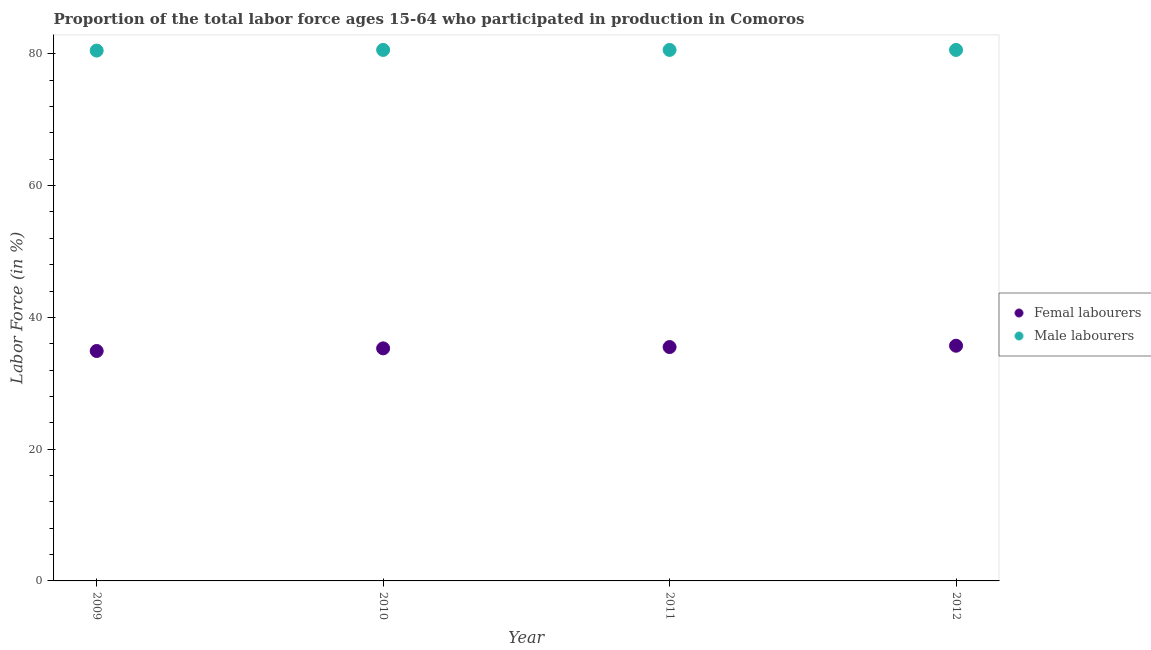What is the percentage of female labor force in 2011?
Your answer should be very brief. 35.5. Across all years, what is the maximum percentage of female labor force?
Offer a terse response. 35.7. Across all years, what is the minimum percentage of female labor force?
Your answer should be very brief. 34.9. In which year was the percentage of female labor force minimum?
Your response must be concise. 2009. What is the total percentage of male labour force in the graph?
Offer a terse response. 322.3. What is the difference between the percentage of male labour force in 2009 and that in 2012?
Make the answer very short. -0.1. What is the difference between the percentage of female labor force in 2011 and the percentage of male labour force in 2012?
Offer a very short reply. -45.1. What is the average percentage of male labour force per year?
Your answer should be compact. 80.57. In the year 2010, what is the difference between the percentage of male labour force and percentage of female labor force?
Provide a short and direct response. 45.3. In how many years, is the percentage of female labor force greater than 32 %?
Give a very brief answer. 4. What is the ratio of the percentage of male labour force in 2009 to that in 2011?
Ensure brevity in your answer.  1. Is the difference between the percentage of male labour force in 2010 and 2011 greater than the difference between the percentage of female labor force in 2010 and 2011?
Offer a very short reply. Yes. What is the difference between the highest and the second highest percentage of female labor force?
Ensure brevity in your answer.  0.2. What is the difference between the highest and the lowest percentage of male labour force?
Ensure brevity in your answer.  0.1. In how many years, is the percentage of male labour force greater than the average percentage of male labour force taken over all years?
Your answer should be compact. 3. Is the sum of the percentage of male labour force in 2010 and 2012 greater than the maximum percentage of female labor force across all years?
Your response must be concise. Yes. Is the percentage of male labour force strictly less than the percentage of female labor force over the years?
Your response must be concise. No. How many years are there in the graph?
Your response must be concise. 4. What is the difference between two consecutive major ticks on the Y-axis?
Offer a terse response. 20. Does the graph contain any zero values?
Give a very brief answer. No. Does the graph contain grids?
Make the answer very short. No. Where does the legend appear in the graph?
Your answer should be very brief. Center right. How many legend labels are there?
Offer a very short reply. 2. How are the legend labels stacked?
Your answer should be very brief. Vertical. What is the title of the graph?
Make the answer very short. Proportion of the total labor force ages 15-64 who participated in production in Comoros. Does "% of GNI" appear as one of the legend labels in the graph?
Your response must be concise. No. What is the label or title of the X-axis?
Offer a very short reply. Year. What is the label or title of the Y-axis?
Offer a terse response. Labor Force (in %). What is the Labor Force (in %) of Femal labourers in 2009?
Offer a very short reply. 34.9. What is the Labor Force (in %) of Male labourers in 2009?
Provide a short and direct response. 80.5. What is the Labor Force (in %) of Femal labourers in 2010?
Your answer should be compact. 35.3. What is the Labor Force (in %) in Male labourers in 2010?
Your answer should be very brief. 80.6. What is the Labor Force (in %) of Femal labourers in 2011?
Your answer should be very brief. 35.5. What is the Labor Force (in %) in Male labourers in 2011?
Offer a very short reply. 80.6. What is the Labor Force (in %) in Femal labourers in 2012?
Make the answer very short. 35.7. What is the Labor Force (in %) in Male labourers in 2012?
Offer a very short reply. 80.6. Across all years, what is the maximum Labor Force (in %) of Femal labourers?
Provide a short and direct response. 35.7. Across all years, what is the maximum Labor Force (in %) in Male labourers?
Make the answer very short. 80.6. Across all years, what is the minimum Labor Force (in %) in Femal labourers?
Offer a terse response. 34.9. Across all years, what is the minimum Labor Force (in %) in Male labourers?
Your response must be concise. 80.5. What is the total Labor Force (in %) in Femal labourers in the graph?
Your response must be concise. 141.4. What is the total Labor Force (in %) in Male labourers in the graph?
Offer a very short reply. 322.3. What is the difference between the Labor Force (in %) of Male labourers in 2009 and that in 2010?
Offer a very short reply. -0.1. What is the difference between the Labor Force (in %) of Femal labourers in 2009 and that in 2011?
Your answer should be compact. -0.6. What is the difference between the Labor Force (in %) in Femal labourers in 2011 and that in 2012?
Your response must be concise. -0.2. What is the difference between the Labor Force (in %) in Femal labourers in 2009 and the Labor Force (in %) in Male labourers in 2010?
Provide a succinct answer. -45.7. What is the difference between the Labor Force (in %) in Femal labourers in 2009 and the Labor Force (in %) in Male labourers in 2011?
Keep it short and to the point. -45.7. What is the difference between the Labor Force (in %) in Femal labourers in 2009 and the Labor Force (in %) in Male labourers in 2012?
Your answer should be very brief. -45.7. What is the difference between the Labor Force (in %) of Femal labourers in 2010 and the Labor Force (in %) of Male labourers in 2011?
Keep it short and to the point. -45.3. What is the difference between the Labor Force (in %) in Femal labourers in 2010 and the Labor Force (in %) in Male labourers in 2012?
Give a very brief answer. -45.3. What is the difference between the Labor Force (in %) of Femal labourers in 2011 and the Labor Force (in %) of Male labourers in 2012?
Ensure brevity in your answer.  -45.1. What is the average Labor Force (in %) in Femal labourers per year?
Make the answer very short. 35.35. What is the average Labor Force (in %) in Male labourers per year?
Ensure brevity in your answer.  80.58. In the year 2009, what is the difference between the Labor Force (in %) in Femal labourers and Labor Force (in %) in Male labourers?
Make the answer very short. -45.6. In the year 2010, what is the difference between the Labor Force (in %) in Femal labourers and Labor Force (in %) in Male labourers?
Your answer should be very brief. -45.3. In the year 2011, what is the difference between the Labor Force (in %) of Femal labourers and Labor Force (in %) of Male labourers?
Your answer should be compact. -45.1. In the year 2012, what is the difference between the Labor Force (in %) of Femal labourers and Labor Force (in %) of Male labourers?
Provide a short and direct response. -44.9. What is the ratio of the Labor Force (in %) of Femal labourers in 2009 to that in 2010?
Your answer should be very brief. 0.99. What is the ratio of the Labor Force (in %) of Male labourers in 2009 to that in 2010?
Keep it short and to the point. 1. What is the ratio of the Labor Force (in %) of Femal labourers in 2009 to that in 2011?
Your answer should be very brief. 0.98. What is the ratio of the Labor Force (in %) in Femal labourers in 2009 to that in 2012?
Your answer should be very brief. 0.98. What is the ratio of the Labor Force (in %) of Femal labourers in 2010 to that in 2011?
Offer a terse response. 0.99. What is the ratio of the Labor Force (in %) in Male labourers in 2010 to that in 2011?
Offer a terse response. 1. What is the ratio of the Labor Force (in %) of Femal labourers in 2010 to that in 2012?
Provide a succinct answer. 0.99. What is the difference between the highest and the lowest Labor Force (in %) in Femal labourers?
Offer a terse response. 0.8. 